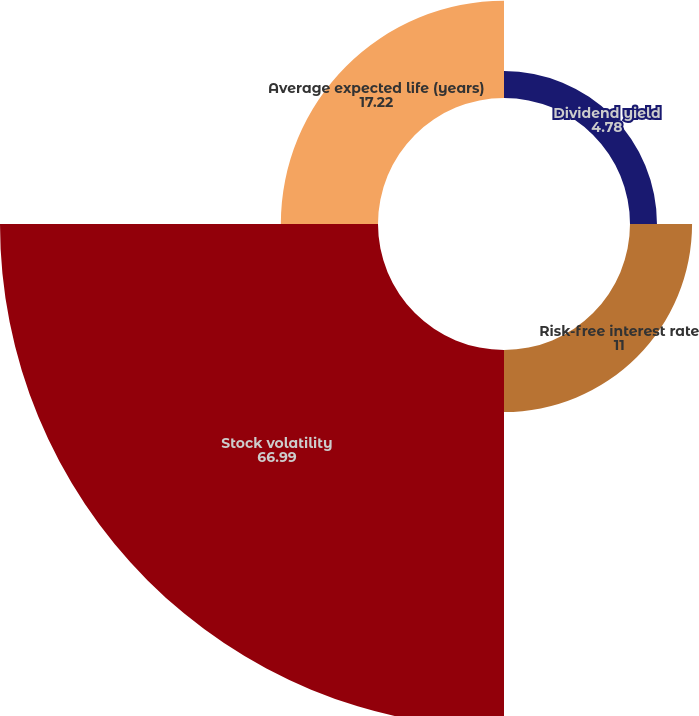<chart> <loc_0><loc_0><loc_500><loc_500><pie_chart><fcel>Dividend yield<fcel>Risk-free interest rate<fcel>Stock volatility<fcel>Average expected life (years)<nl><fcel>4.78%<fcel>11.0%<fcel>66.99%<fcel>17.22%<nl></chart> 